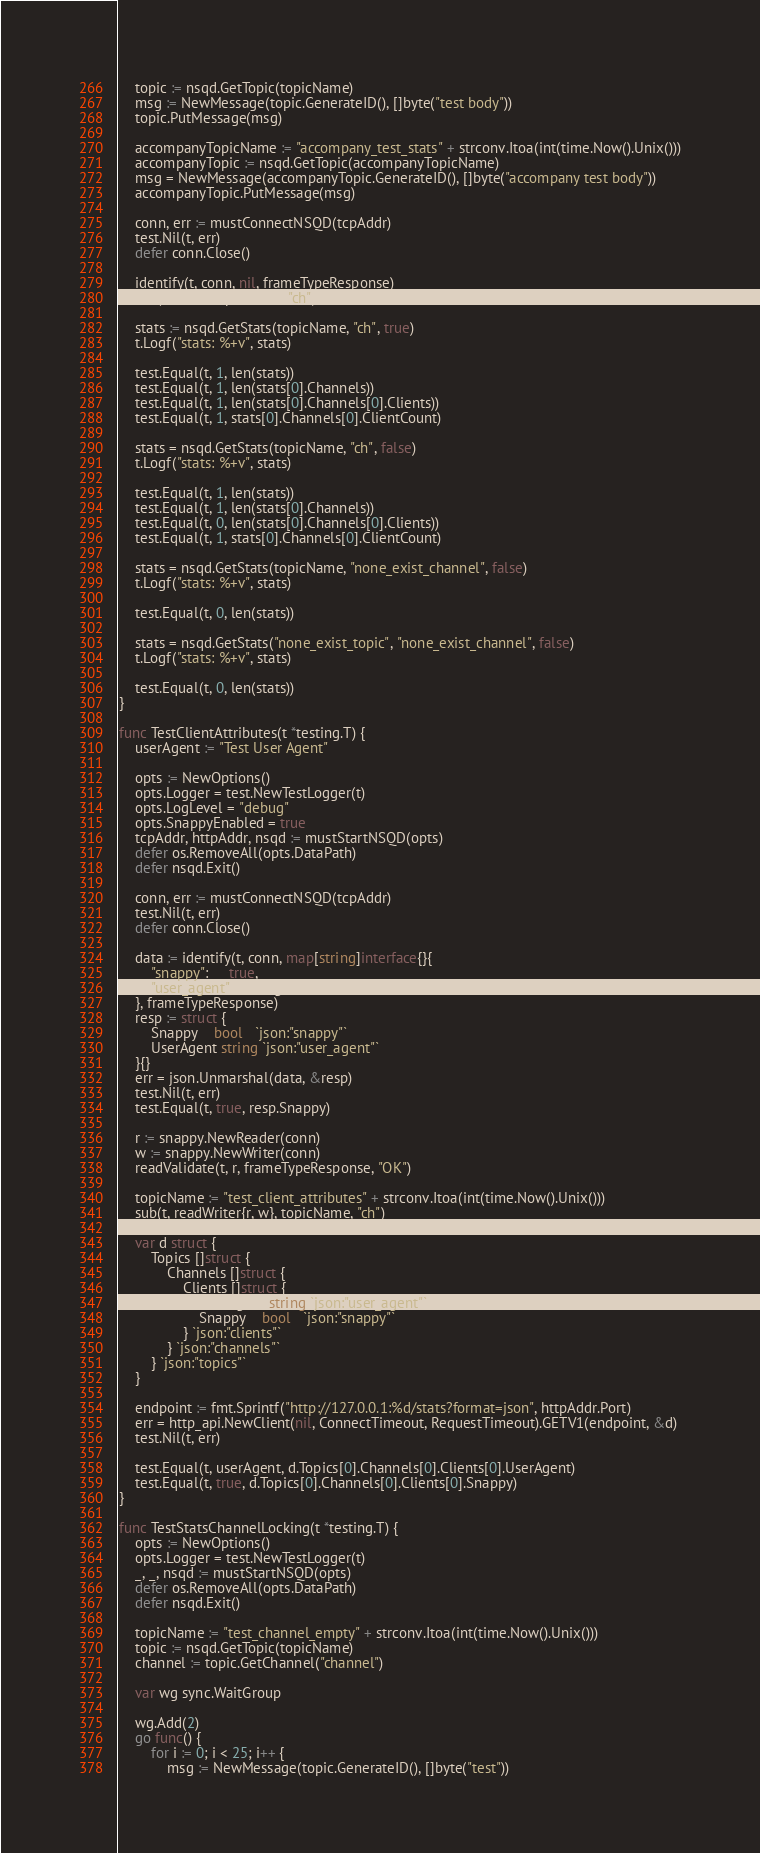<code> <loc_0><loc_0><loc_500><loc_500><_Go_>	topic := nsqd.GetTopic(topicName)
	msg := NewMessage(topic.GenerateID(), []byte("test body"))
	topic.PutMessage(msg)

	accompanyTopicName := "accompany_test_stats" + strconv.Itoa(int(time.Now().Unix()))
	accompanyTopic := nsqd.GetTopic(accompanyTopicName)
	msg = NewMessage(accompanyTopic.GenerateID(), []byte("accompany test body"))
	accompanyTopic.PutMessage(msg)

	conn, err := mustConnectNSQD(tcpAddr)
	test.Nil(t, err)
	defer conn.Close()

	identify(t, conn, nil, frameTypeResponse)
	sub(t, conn, topicName, "ch")

	stats := nsqd.GetStats(topicName, "ch", true)
	t.Logf("stats: %+v", stats)

	test.Equal(t, 1, len(stats))
	test.Equal(t, 1, len(stats[0].Channels))
	test.Equal(t, 1, len(stats[0].Channels[0].Clients))
	test.Equal(t, 1, stats[0].Channels[0].ClientCount)

	stats = nsqd.GetStats(topicName, "ch", false)
	t.Logf("stats: %+v", stats)

	test.Equal(t, 1, len(stats))
	test.Equal(t, 1, len(stats[0].Channels))
	test.Equal(t, 0, len(stats[0].Channels[0].Clients))
	test.Equal(t, 1, stats[0].Channels[0].ClientCount)

	stats = nsqd.GetStats(topicName, "none_exist_channel", false)
	t.Logf("stats: %+v", stats)

	test.Equal(t, 0, len(stats))

	stats = nsqd.GetStats("none_exist_topic", "none_exist_channel", false)
	t.Logf("stats: %+v", stats)

	test.Equal(t, 0, len(stats))
}

func TestClientAttributes(t *testing.T) {
	userAgent := "Test User Agent"

	opts := NewOptions()
	opts.Logger = test.NewTestLogger(t)
	opts.LogLevel = "debug"
	opts.SnappyEnabled = true
	tcpAddr, httpAddr, nsqd := mustStartNSQD(opts)
	defer os.RemoveAll(opts.DataPath)
	defer nsqd.Exit()

	conn, err := mustConnectNSQD(tcpAddr)
	test.Nil(t, err)
	defer conn.Close()

	data := identify(t, conn, map[string]interface{}{
		"snappy":     true,
		"user_agent": userAgent,
	}, frameTypeResponse)
	resp := struct {
		Snappy    bool   `json:"snappy"`
		UserAgent string `json:"user_agent"`
	}{}
	err = json.Unmarshal(data, &resp)
	test.Nil(t, err)
	test.Equal(t, true, resp.Snappy)

	r := snappy.NewReader(conn)
	w := snappy.NewWriter(conn)
	readValidate(t, r, frameTypeResponse, "OK")

	topicName := "test_client_attributes" + strconv.Itoa(int(time.Now().Unix()))
	sub(t, readWriter{r, w}, topicName, "ch")

	var d struct {
		Topics []struct {
			Channels []struct {
				Clients []struct {
					UserAgent string `json:"user_agent"`
					Snappy    bool   `json:"snappy"`
				} `json:"clients"`
			} `json:"channels"`
		} `json:"topics"`
	}

	endpoint := fmt.Sprintf("http://127.0.0.1:%d/stats?format=json", httpAddr.Port)
	err = http_api.NewClient(nil, ConnectTimeout, RequestTimeout).GETV1(endpoint, &d)
	test.Nil(t, err)

	test.Equal(t, userAgent, d.Topics[0].Channels[0].Clients[0].UserAgent)
	test.Equal(t, true, d.Topics[0].Channels[0].Clients[0].Snappy)
}

func TestStatsChannelLocking(t *testing.T) {
	opts := NewOptions()
	opts.Logger = test.NewTestLogger(t)
	_, _, nsqd := mustStartNSQD(opts)
	defer os.RemoveAll(opts.DataPath)
	defer nsqd.Exit()

	topicName := "test_channel_empty" + strconv.Itoa(int(time.Now().Unix()))
	topic := nsqd.GetTopic(topicName)
	channel := topic.GetChannel("channel")

	var wg sync.WaitGroup

	wg.Add(2)
	go func() {
		for i := 0; i < 25; i++ {
			msg := NewMessage(topic.GenerateID(), []byte("test"))</code> 